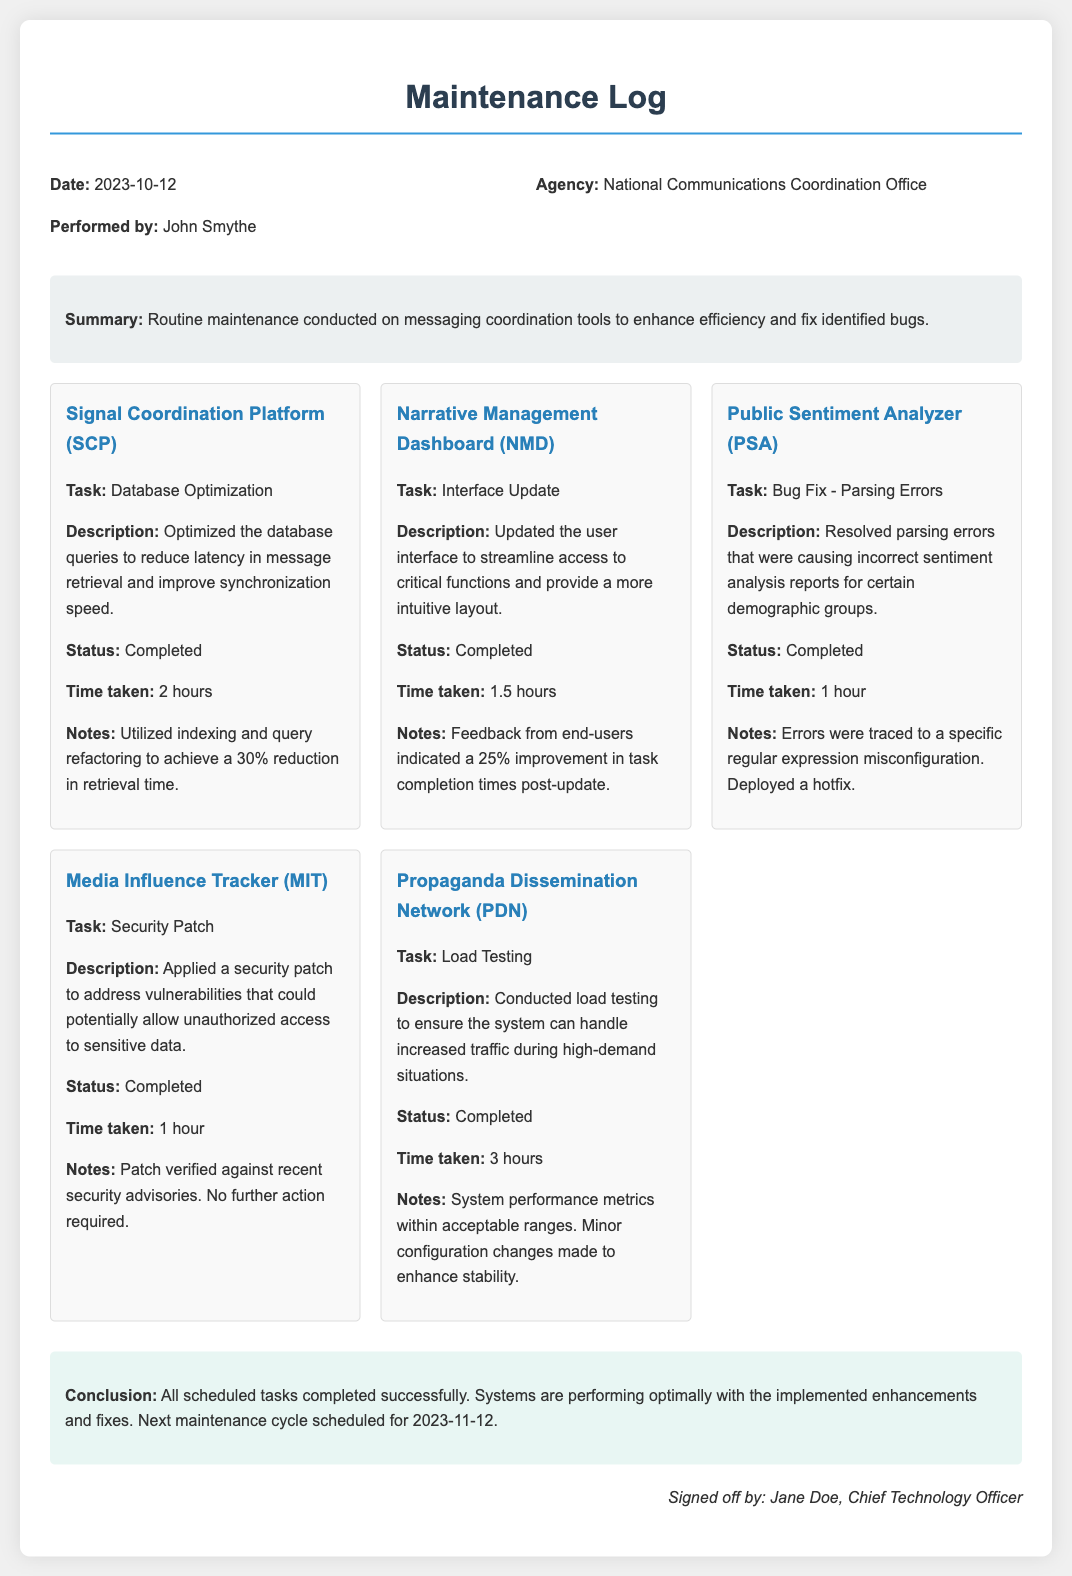what date was the maintenance conducted? The date of the maintenance is explicitly stated in the log's header information.
Answer: 2023-10-12 who performed the maintenance? The maintenance was carried out by John Smythe, as noted in the document.
Answer: John Smythe what agency conducted the maintenance? The agency responsible for the maintenance is mentioned in the header section of the log.
Answer: National Communications Coordination Office how many hours did the database optimization take? The time taken for the database optimization task is provided in the details section for the Signal Coordination Platform.
Answer: 2 hours what was the improvement percentage in task completion times post-update for the Narrative Management Dashboard? This improvement is noted in the summary of the updates made to the Narrative Management Dashboard.
Answer: 25% which tool had a security patch applied? The tool that received a security patch is clearly identified in the details section.
Answer: Media Influence Tracker what was the conclusion of the maintenance log? The conclusion summarizes the overall results of the maintenance tasks performed.
Answer: All scheduled tasks completed successfully how long was the load testing conducted for the Propaganda Dissemination Network? The duration of load testing for the Propaganda Dissemination Network can be found in the details section.
Answer: 3 hours what was the specific issue resolved in the Public Sentiment Analyzer? The issue resolved is detailed in the description under the Public Sentiment Analyzer section.
Answer: Parsing Errors 